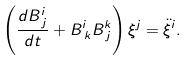Convert formula to latex. <formula><loc_0><loc_0><loc_500><loc_500>\left ( \frac { d B ^ { i } _ { \, j } } { d t } + B ^ { i } _ { \, k } B ^ { k } _ { \, j } \right ) \xi ^ { j } = { \ddot { \xi } } ^ { i } .</formula> 